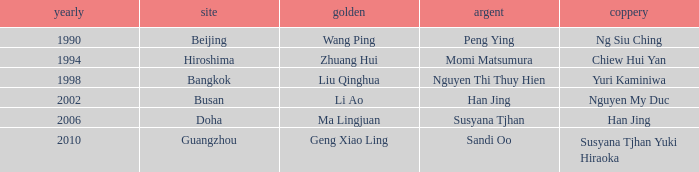What Silver has the Location of Guangzhou? Sandi Oo. 